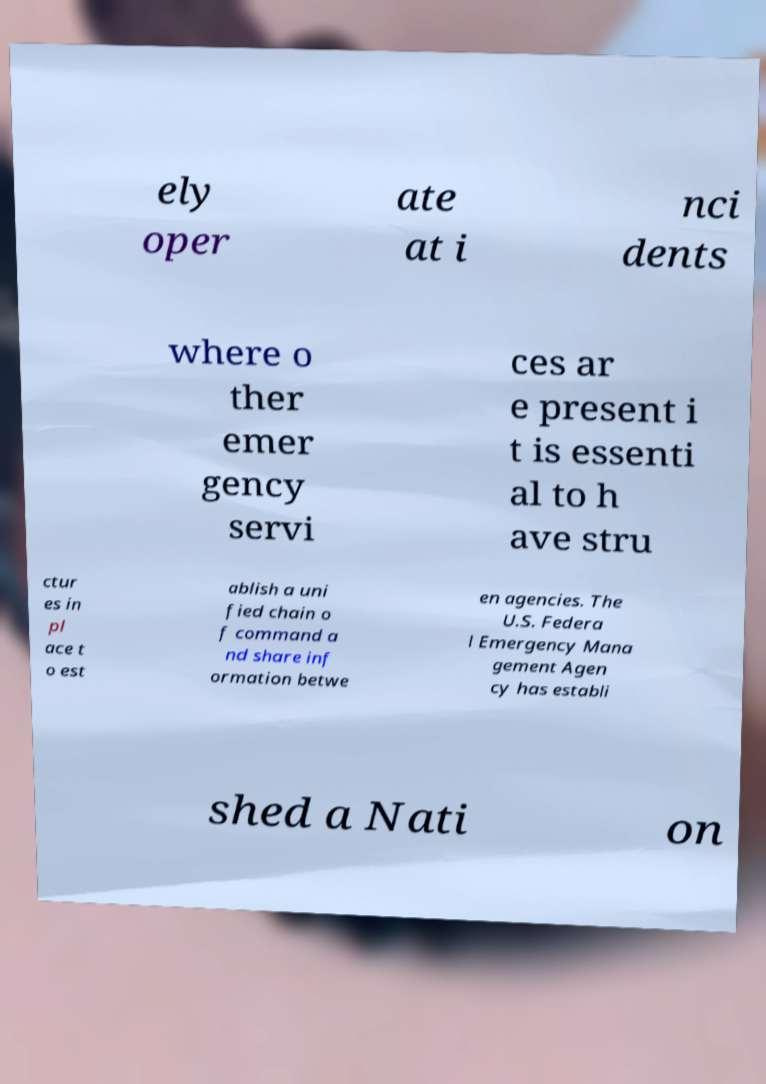Please read and relay the text visible in this image. What does it say? ely oper ate at i nci dents where o ther emer gency servi ces ar e present i t is essenti al to h ave stru ctur es in pl ace t o est ablish a uni fied chain o f command a nd share inf ormation betwe en agencies. The U.S. Federa l Emergency Mana gement Agen cy has establi shed a Nati on 